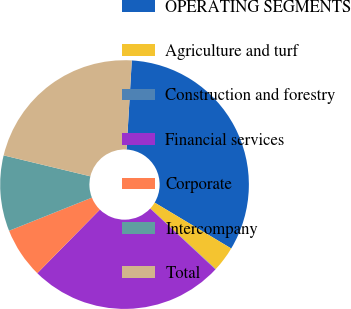<chart> <loc_0><loc_0><loc_500><loc_500><pie_chart><fcel>OPERATING SEGMENTS<fcel>Agriculture and turf<fcel>Construction and forestry<fcel>Financial services<fcel>Corporate<fcel>Intercompany<fcel>Total<nl><fcel>32.66%<fcel>3.31%<fcel>0.05%<fcel>25.42%<fcel>6.57%<fcel>9.83%<fcel>22.16%<nl></chart> 